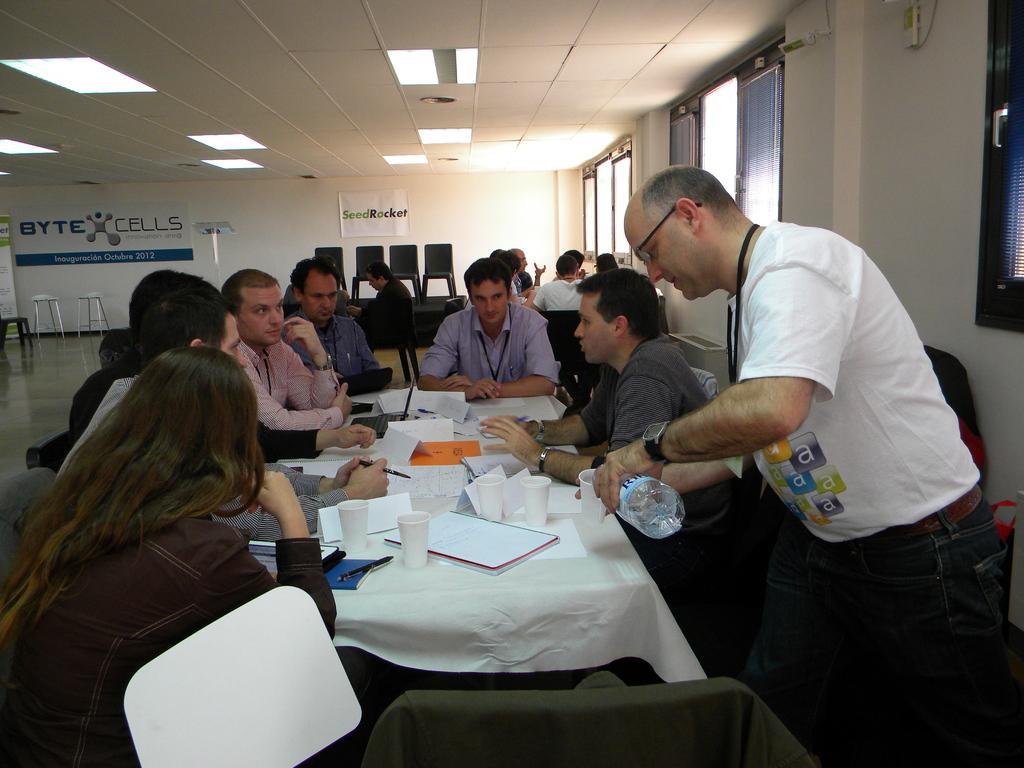How would you summarize this image in a sentence or two? In the image we can see there are people who are sitting around a table and the people are looking at each other. On the table there are papers and glasses. There is a man who is standing here is pouring a water into a glass and at the back there are people sitting on the chairs. 